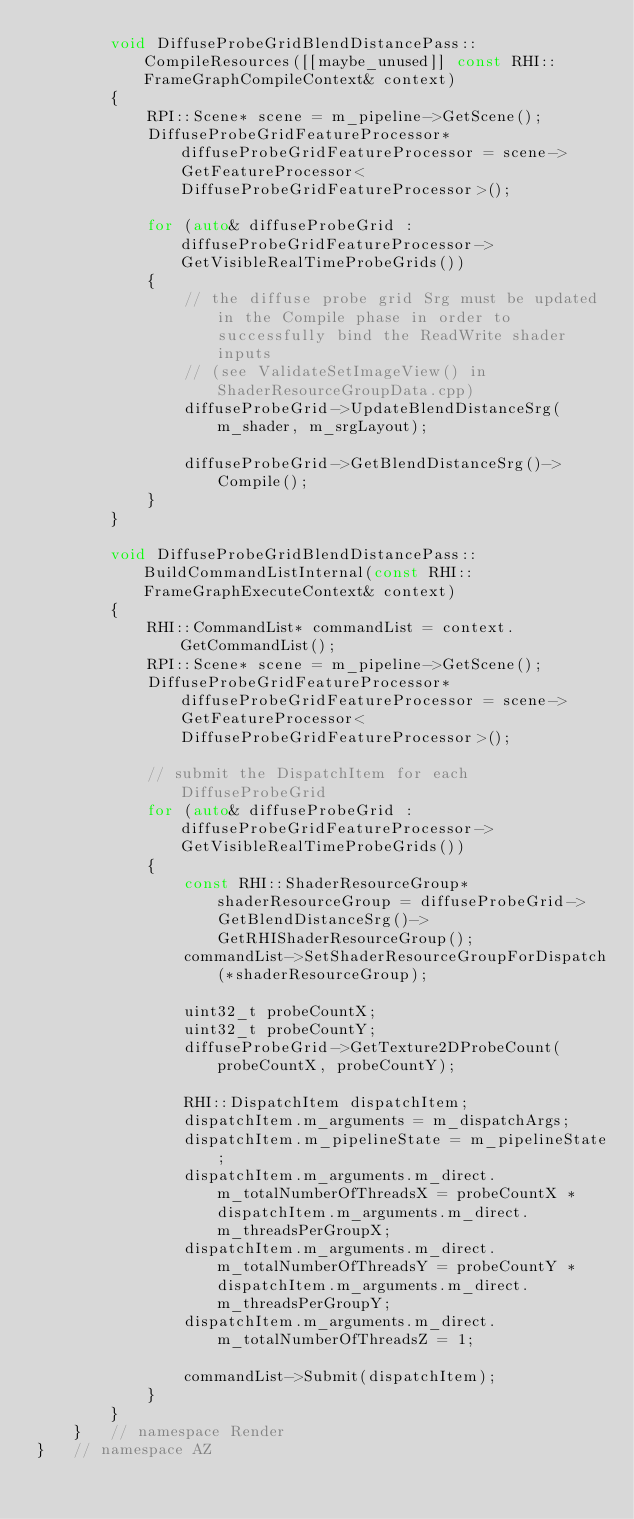<code> <loc_0><loc_0><loc_500><loc_500><_C++_>        void DiffuseProbeGridBlendDistancePass::CompileResources([[maybe_unused]] const RHI::FrameGraphCompileContext& context)
        {
            RPI::Scene* scene = m_pipeline->GetScene();
            DiffuseProbeGridFeatureProcessor* diffuseProbeGridFeatureProcessor = scene->GetFeatureProcessor<DiffuseProbeGridFeatureProcessor>();

            for (auto& diffuseProbeGrid : diffuseProbeGridFeatureProcessor->GetVisibleRealTimeProbeGrids())
            {
                // the diffuse probe grid Srg must be updated in the Compile phase in order to successfully bind the ReadWrite shader inputs
                // (see ValidateSetImageView() in ShaderResourceGroupData.cpp)
                diffuseProbeGrid->UpdateBlendDistanceSrg(m_shader, m_srgLayout);

                diffuseProbeGrid->GetBlendDistanceSrg()->Compile();
            }
        }

        void DiffuseProbeGridBlendDistancePass::BuildCommandListInternal(const RHI::FrameGraphExecuteContext& context)
        {
            RHI::CommandList* commandList = context.GetCommandList();
            RPI::Scene* scene = m_pipeline->GetScene();
            DiffuseProbeGridFeatureProcessor* diffuseProbeGridFeatureProcessor = scene->GetFeatureProcessor<DiffuseProbeGridFeatureProcessor>();

            // submit the DispatchItem for each DiffuseProbeGrid
            for (auto& diffuseProbeGrid : diffuseProbeGridFeatureProcessor->GetVisibleRealTimeProbeGrids())
            {
                const RHI::ShaderResourceGroup* shaderResourceGroup = diffuseProbeGrid->GetBlendDistanceSrg()->GetRHIShaderResourceGroup();
                commandList->SetShaderResourceGroupForDispatch(*shaderResourceGroup);

                uint32_t probeCountX;
                uint32_t probeCountY;
                diffuseProbeGrid->GetTexture2DProbeCount(probeCountX, probeCountY);

                RHI::DispatchItem dispatchItem;
                dispatchItem.m_arguments = m_dispatchArgs;
                dispatchItem.m_pipelineState = m_pipelineState;
                dispatchItem.m_arguments.m_direct.m_totalNumberOfThreadsX = probeCountX * dispatchItem.m_arguments.m_direct.m_threadsPerGroupX;
                dispatchItem.m_arguments.m_direct.m_totalNumberOfThreadsY = probeCountY * dispatchItem.m_arguments.m_direct.m_threadsPerGroupY;
                dispatchItem.m_arguments.m_direct.m_totalNumberOfThreadsZ = 1;

                commandList->Submit(dispatchItem);
            }
        }
    }   // namespace Render
}   // namespace AZ
</code> 